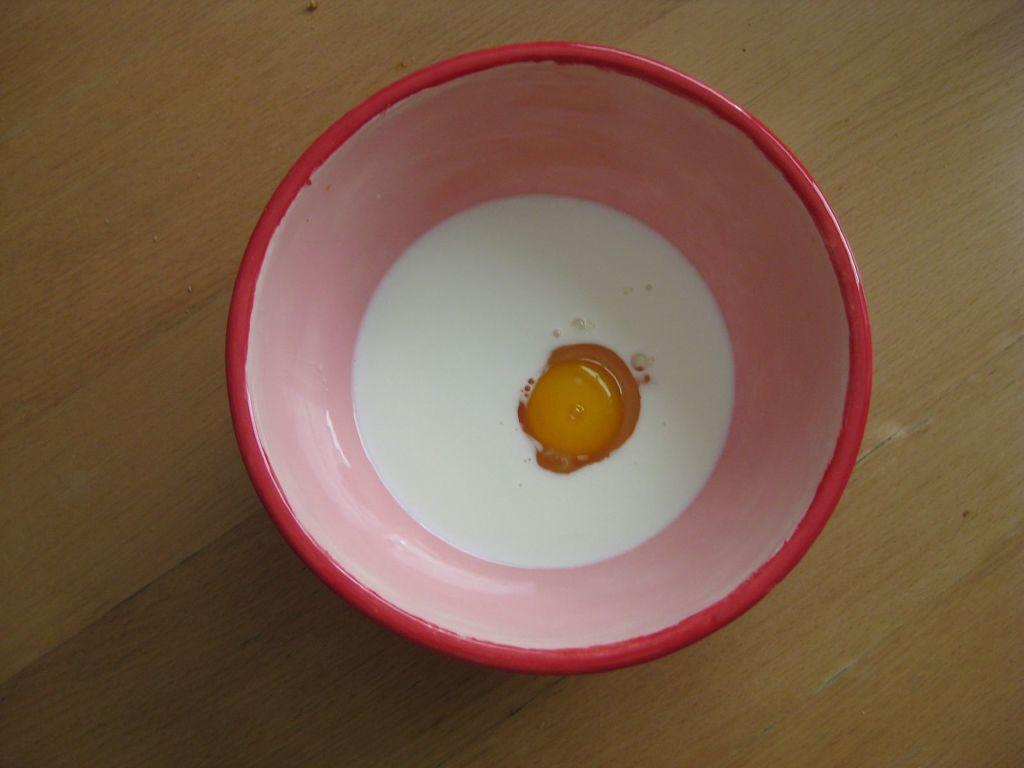What is in the bowl that is visible in the image? There is milk and yolk in the bowl. What type of surface is at the bottom of the image? There is a wooden surface at the bottom of the image. What type of sweater is visible in the image? There is no sweater present in the image. 